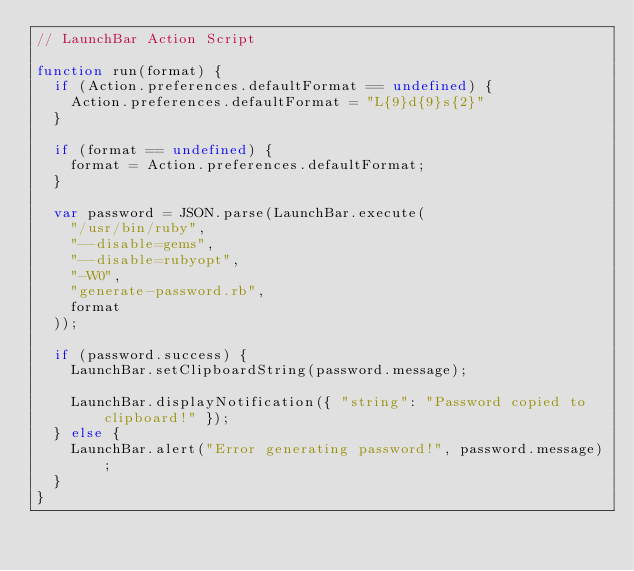Convert code to text. <code><loc_0><loc_0><loc_500><loc_500><_JavaScript_>// LaunchBar Action Script

function run(format) {
  if (Action.preferences.defaultFormat == undefined) {
    Action.preferences.defaultFormat = "L{9}d{9}s{2}"
  }

  if (format == undefined) {
    format = Action.preferences.defaultFormat;
  }

  var password = JSON.parse(LaunchBar.execute(
    "/usr/bin/ruby",
    "--disable=gems",
    "--disable=rubyopt",
    "-W0",
    "generate-password.rb",
    format
  ));

  if (password.success) {
    LaunchBar.setClipboardString(password.message);

    LaunchBar.displayNotification({ "string": "Password copied to clipboard!" });
  } else {
    LaunchBar.alert("Error generating password!", password.message);
  }
}
</code> 